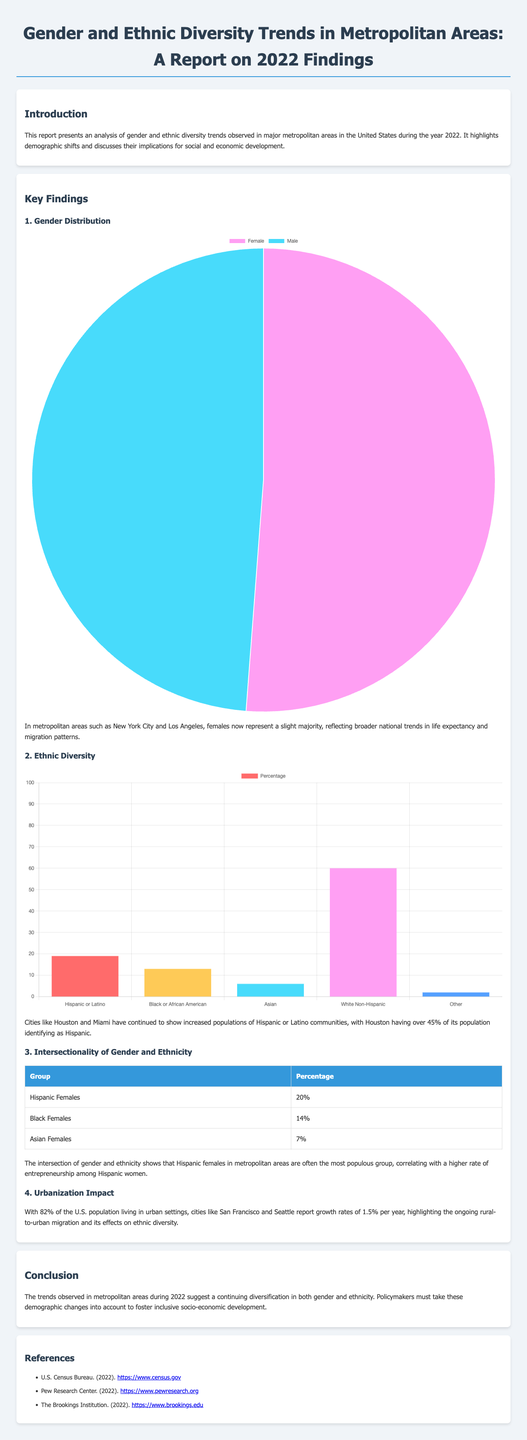What percentage of the population in Houston identifies as Hispanic? The document states that Houston has over 45% of its population identifying as Hispanic.
Answer: Over 45% What is the percentage of Hispanic females in metropolitan areas? The document provides data indicating that Hispanic females make up 20% of certain metropolitan areas.
Answer: 20% Which city has a female majority according to the gender distribution findings? The report mentions New York City and Los Angeles as having a slight female majority.
Answer: New York City and Los Angeles What is the percentage of Black females in metropolitan areas? The percentage of Black females identified in the document is 14%.
Answer: 14% What is the growth rate of cities like San Francisco and Seattle? The report highlights a growth rate of 1.5% per year for these cities.
Answer: 1.5% Which ethnic group has the highest percentage in metropolitan areas? The document indicates that White Non-Hispanic individuals represent the majority at 60%.
Answer: White Non-Hispanic What type of migration is impacting urbanization according to the report? The report identifies rural-to-urban migration as the factor affecting urbanization.
Answer: Rural-to-urban migration What is the total percentage of Asian females in metropolitan areas? The document states that Asian females comprise 7% of the population.
Answer: 7% What overarching trend is observed in the report regarding gender and ethnicity? The conclusion mentions a continuing diversification in both gender and ethnicity in metropolitan areas.
Answer: Diversification in both gender and ethnicity 